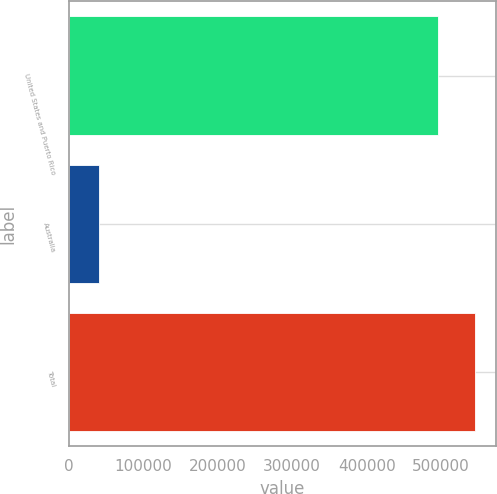<chart> <loc_0><loc_0><loc_500><loc_500><bar_chart><fcel>United States and Puerto Rico<fcel>Australia<fcel>Total<nl><fcel>496368<fcel>41097<fcel>546005<nl></chart> 